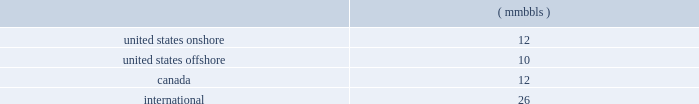46 d e v o n e n e r g y a n n u a l r e p o r t 2 0 0 4 contents of gas produced , transportation availability and costs and demand for the various products derived from oil , natural gas and ngls .
Substantially all of devon 2019s revenues are attributable to sales , processing and transportation of these three commodities .
Consequently , our financial results and resources are highly influenced by price volatility .
Estimates for devon 2019s future production of oil , natural gas and ngls are based on the assumption that market demand and prices will continue at levels that allow for profitable production of these products .
There can be no assurance of such stability .
Most of our canadian production is subject to government royalties that fluctuate with prices .
Thus , price fluctuations can affect reported production .
Also , our international production is governed by payout agreements with the governments of the countries in which we operate .
If the payout under these agreements is attained earlier than projected , devon 2019s net production and proved reserves in such areas could be reduced .
Estimates for our future processing and transport of oil , natural gas and ngls are based on the assumption that market demand and prices will continue at levels that allow for profitable processing and transport of these products .
There can be no assurance of such stability .
The production , transportation , processing and marketing of oil , natural gas and ngls are complex processes which are subject to disruption from many causes .
These causes include transportation and processing availability , mechanical failure , human error , meteorological events including , but not limited to , hurricanes , and numerous other factors .
The following forward-looking statements were prepared assuming demand , curtailment , producibility and general market conditions for devon 2019s oil , natural gas and ngls during 2005 will be substantially similar to those of 2004 , unless otherwise noted .
Unless otherwise noted , all of the following dollar amounts are expressed in u.s .
Dollars .
Amounts related to canadian operations have been converted to u.s .
Dollars using a projected average 2005 exchange rate of $ 0.82 u.s .
To $ 1.00 canadian .
The actual 2005 exchange rate may vary materially from this estimate .
Such variations could have a material effect on the following estimates .
Though we have completed several major property acquisitions and dispositions in recent years , these transactions are opportunity driven .
Thus , the following forward-looking data excludes the financial and operating effects of potential property acquisitions or divestitures , except as discussed in 201cproperty acquisitions and divestitures , 201d during the year 2005 .
The timing and ultimate results of such acquisition and divestiture activity is difficult to predict , and may vary materially from that discussed in this report .
Geographic reporting areas for 2005 the following estimates of production , average price differentials and capital expenditures are provided separately for each of the following geographic areas : 2022 the united states onshore ; 2022 the united states offshore , which encompasses all oil and gas properties in the gulf of mexico ; 2022 canada ; and 2022 international , which encompasses all oil and gas properties that lie outside of the united states and canada .
Year 2005 potential operating items the estimates related to oil , gas and ngl production , operating costs and dd&a set forth in the following paragraphs are based on estimates for devon 2019s properties other than those that have been designated for possible sale ( see 201cproperty acquisitions and divestitures 201d ) .
Therefore , the following estimates exclude the results of the potential sale properties for the entire year .
Oil , gas and ngl production set forth in the following paragraphs are individual estimates of devon 2019s oil , gas and ngl production for 2005 .
On a combined basis , devon estimates its 2005 oil , gas and ngl production will total 217 mmboe .
Of this total , approximately 92% ( 92 % ) is estimated to be produced from reserves classified as 201cproved 201d at december 31 , 2004 .
Oil production we expect our oil production in 2005 to total 60 mmbbls .
Of this total , approximately 95% ( 95 % ) is estimated to be produced from reserves classified as 201cproved 201d at december 31 , 2004 .
The expected production by area is as follows: .
Oil prices 2013 fixed through various price swaps , devon has fixed the price it will receive in 2005 on a portion of its oil production .
The following table includes information on this fixed-price production by area .
Where necessary , the prices have been adjusted for certain transportation costs that are netted against the prices recorded by devon. .
How much of the oil production is estimated to be produced from unproved reserves at dec 31 , 2004 , in mmbbls? 
Computations: (60 * ((100 / 95) / 100))
Answer: 0.63158. 46 d e v o n e n e r g y a n n u a l r e p o r t 2 0 0 4 contents of gas produced , transportation availability and costs and demand for the various products derived from oil , natural gas and ngls .
Substantially all of devon 2019s revenues are attributable to sales , processing and transportation of these three commodities .
Consequently , our financial results and resources are highly influenced by price volatility .
Estimates for devon 2019s future production of oil , natural gas and ngls are based on the assumption that market demand and prices will continue at levels that allow for profitable production of these products .
There can be no assurance of such stability .
Most of our canadian production is subject to government royalties that fluctuate with prices .
Thus , price fluctuations can affect reported production .
Also , our international production is governed by payout agreements with the governments of the countries in which we operate .
If the payout under these agreements is attained earlier than projected , devon 2019s net production and proved reserves in such areas could be reduced .
Estimates for our future processing and transport of oil , natural gas and ngls are based on the assumption that market demand and prices will continue at levels that allow for profitable processing and transport of these products .
There can be no assurance of such stability .
The production , transportation , processing and marketing of oil , natural gas and ngls are complex processes which are subject to disruption from many causes .
These causes include transportation and processing availability , mechanical failure , human error , meteorological events including , but not limited to , hurricanes , and numerous other factors .
The following forward-looking statements were prepared assuming demand , curtailment , producibility and general market conditions for devon 2019s oil , natural gas and ngls during 2005 will be substantially similar to those of 2004 , unless otherwise noted .
Unless otherwise noted , all of the following dollar amounts are expressed in u.s .
Dollars .
Amounts related to canadian operations have been converted to u.s .
Dollars using a projected average 2005 exchange rate of $ 0.82 u.s .
To $ 1.00 canadian .
The actual 2005 exchange rate may vary materially from this estimate .
Such variations could have a material effect on the following estimates .
Though we have completed several major property acquisitions and dispositions in recent years , these transactions are opportunity driven .
Thus , the following forward-looking data excludes the financial and operating effects of potential property acquisitions or divestitures , except as discussed in 201cproperty acquisitions and divestitures , 201d during the year 2005 .
The timing and ultimate results of such acquisition and divestiture activity is difficult to predict , and may vary materially from that discussed in this report .
Geographic reporting areas for 2005 the following estimates of production , average price differentials and capital expenditures are provided separately for each of the following geographic areas : 2022 the united states onshore ; 2022 the united states offshore , which encompasses all oil and gas properties in the gulf of mexico ; 2022 canada ; and 2022 international , which encompasses all oil and gas properties that lie outside of the united states and canada .
Year 2005 potential operating items the estimates related to oil , gas and ngl production , operating costs and dd&a set forth in the following paragraphs are based on estimates for devon 2019s properties other than those that have been designated for possible sale ( see 201cproperty acquisitions and divestitures 201d ) .
Therefore , the following estimates exclude the results of the potential sale properties for the entire year .
Oil , gas and ngl production set forth in the following paragraphs are individual estimates of devon 2019s oil , gas and ngl production for 2005 .
On a combined basis , devon estimates its 2005 oil , gas and ngl production will total 217 mmboe .
Of this total , approximately 92% ( 92 % ) is estimated to be produced from reserves classified as 201cproved 201d at december 31 , 2004 .
Oil production we expect our oil production in 2005 to total 60 mmbbls .
Of this total , approximately 95% ( 95 % ) is estimated to be produced from reserves classified as 201cproved 201d at december 31 , 2004 .
The expected production by area is as follows: .
Oil prices 2013 fixed through various price swaps , devon has fixed the price it will receive in 2005 on a portion of its oil production .
The following table includes information on this fixed-price production by area .
Where necessary , the prices have been adjusted for certain transportation costs that are netted against the prices recorded by devon. .
In 2005 , how much , is us dollars , would $ 20 canadian be? 
Computations: (0.82 * 20)
Answer: 16.4. 